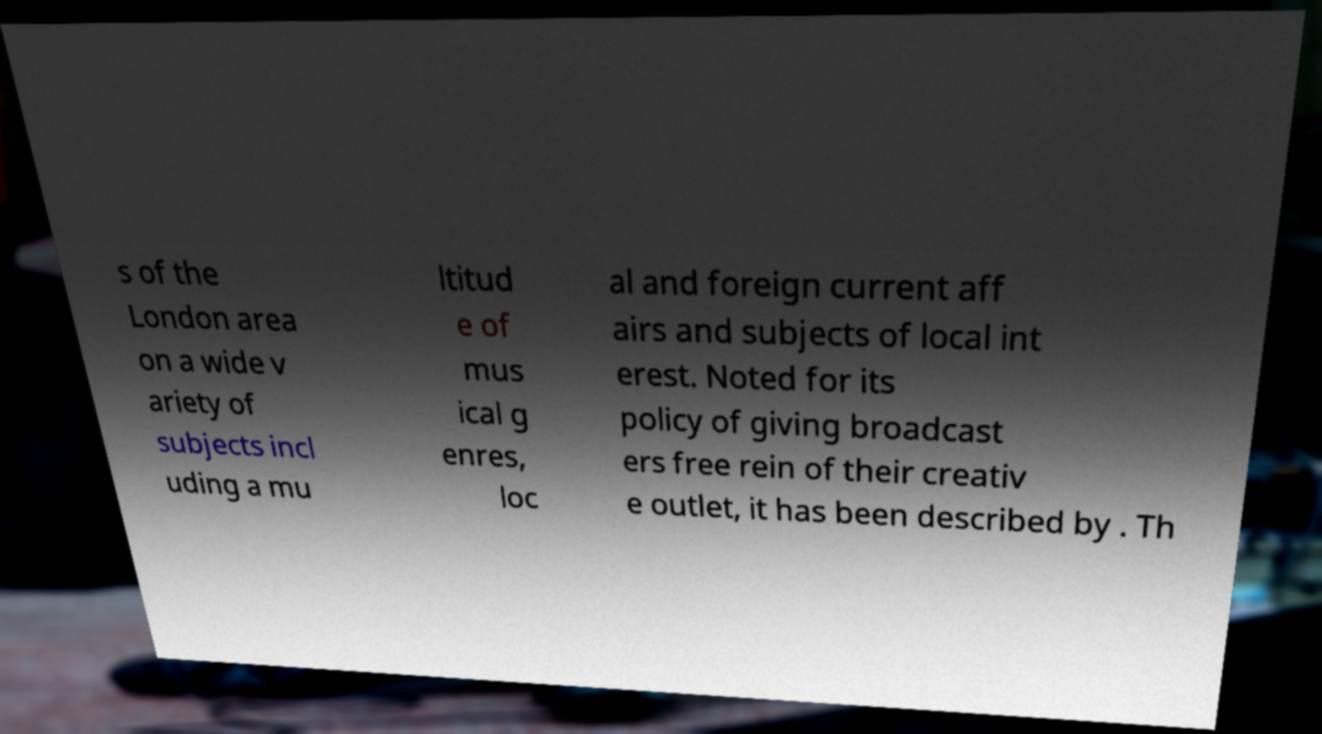There's text embedded in this image that I need extracted. Can you transcribe it verbatim? s of the London area on a wide v ariety of subjects incl uding a mu ltitud e of mus ical g enres, loc al and foreign current aff airs and subjects of local int erest. Noted for its policy of giving broadcast ers free rein of their creativ e outlet, it has been described by . Th 